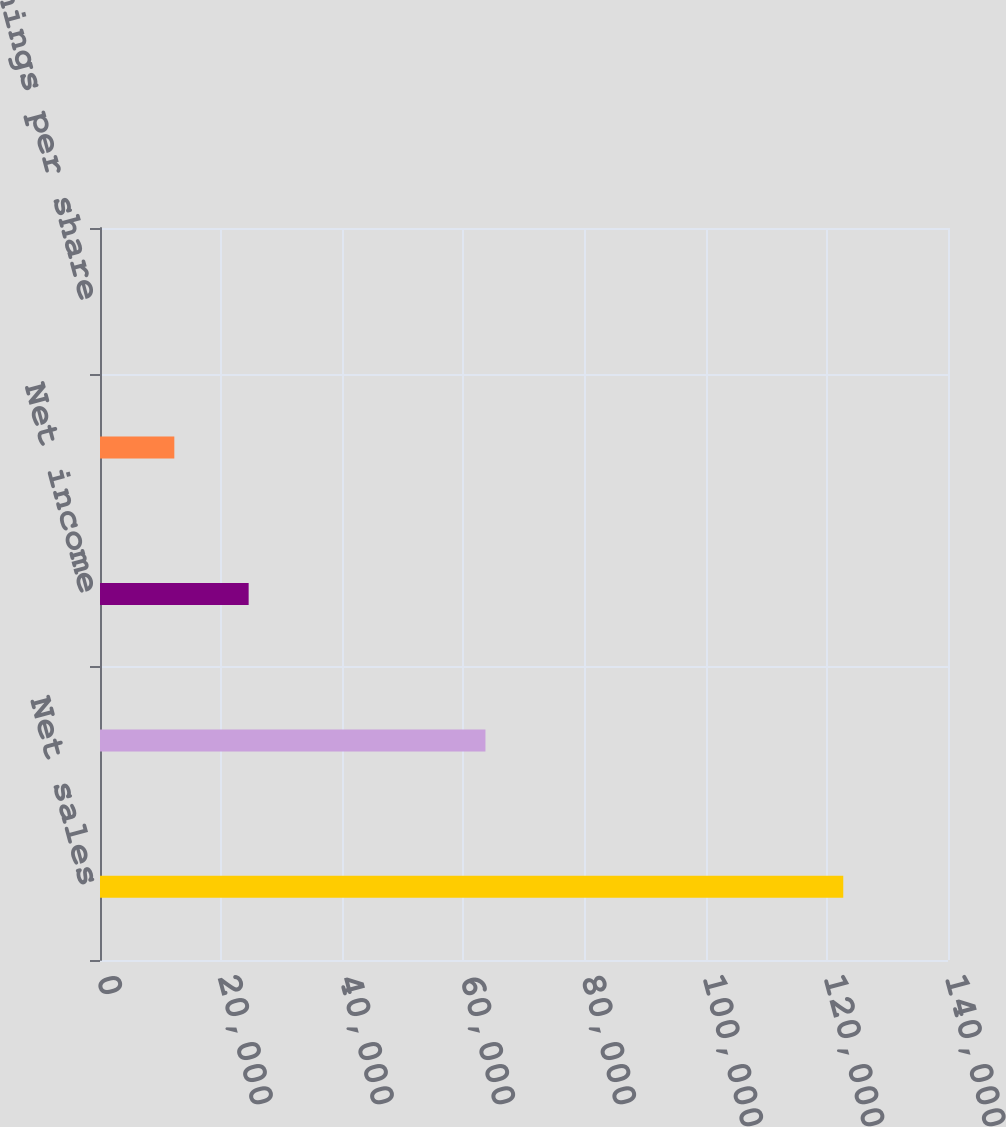<chart> <loc_0><loc_0><loc_500><loc_500><bar_chart><fcel>Net sales<fcel>Gross profit<fcel>Net income<fcel>Basic earnings per share<fcel>Diluted earnings per share<nl><fcel>122709<fcel>63634<fcel>24542.2<fcel>12271.3<fcel>0.43<nl></chart> 